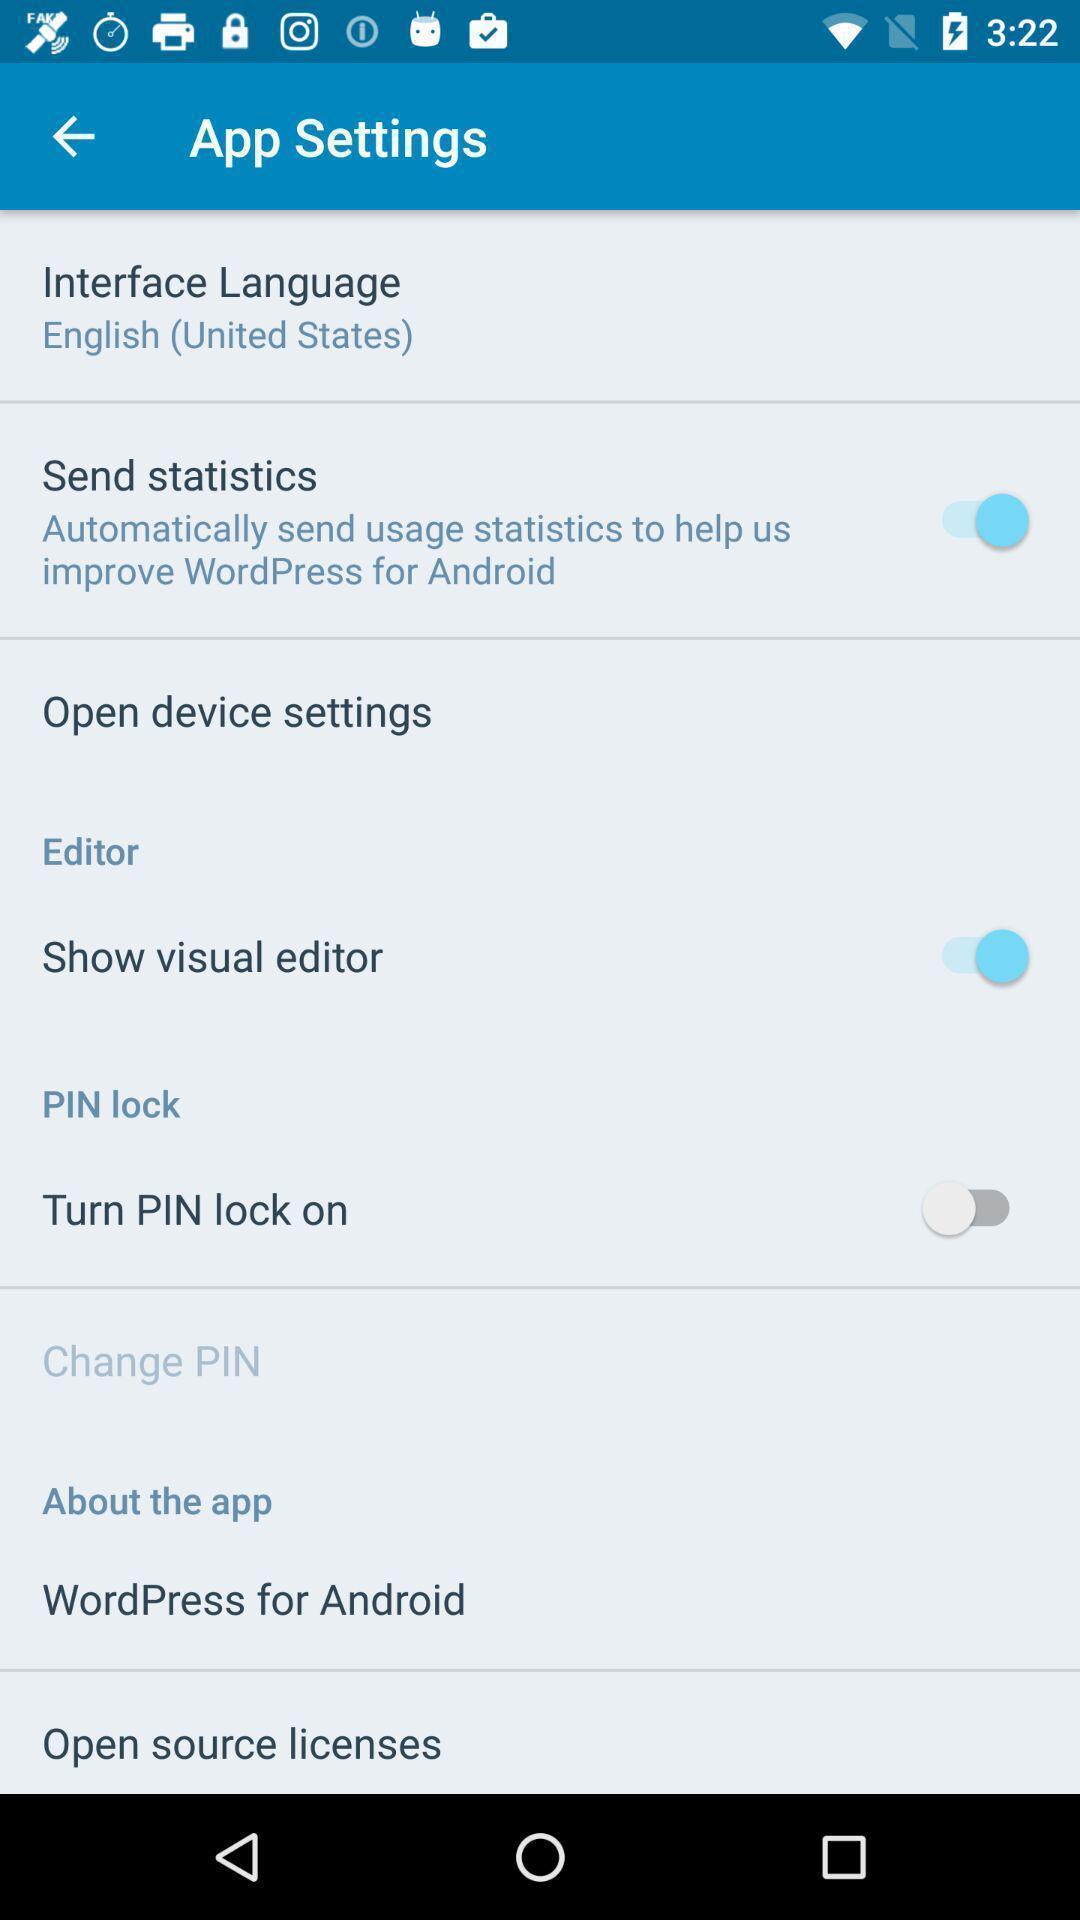Describe this image in words. Settings page displaying various options. 